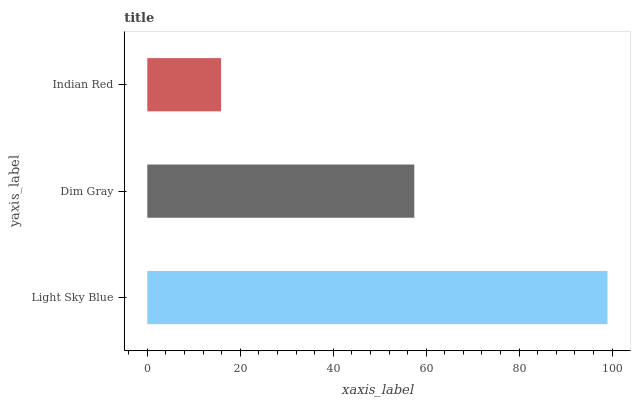Is Indian Red the minimum?
Answer yes or no. Yes. Is Light Sky Blue the maximum?
Answer yes or no. Yes. Is Dim Gray the minimum?
Answer yes or no. No. Is Dim Gray the maximum?
Answer yes or no. No. Is Light Sky Blue greater than Dim Gray?
Answer yes or no. Yes. Is Dim Gray less than Light Sky Blue?
Answer yes or no. Yes. Is Dim Gray greater than Light Sky Blue?
Answer yes or no. No. Is Light Sky Blue less than Dim Gray?
Answer yes or no. No. Is Dim Gray the high median?
Answer yes or no. Yes. Is Dim Gray the low median?
Answer yes or no. Yes. Is Light Sky Blue the high median?
Answer yes or no. No. Is Indian Red the low median?
Answer yes or no. No. 